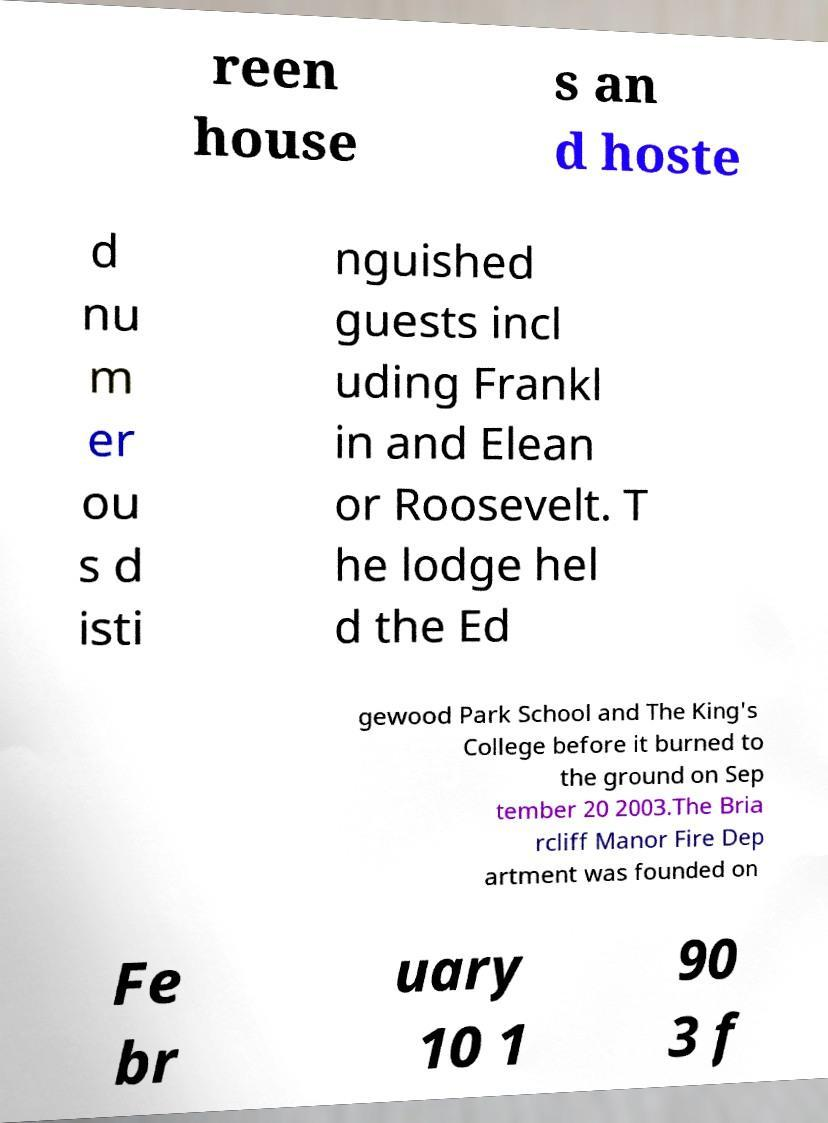Please read and relay the text visible in this image. What does it say? reen house s an d hoste d nu m er ou s d isti nguished guests incl uding Frankl in and Elean or Roosevelt. T he lodge hel d the Ed gewood Park School and The King's College before it burned to the ground on Sep tember 20 2003.The Bria rcliff Manor Fire Dep artment was founded on Fe br uary 10 1 90 3 f 